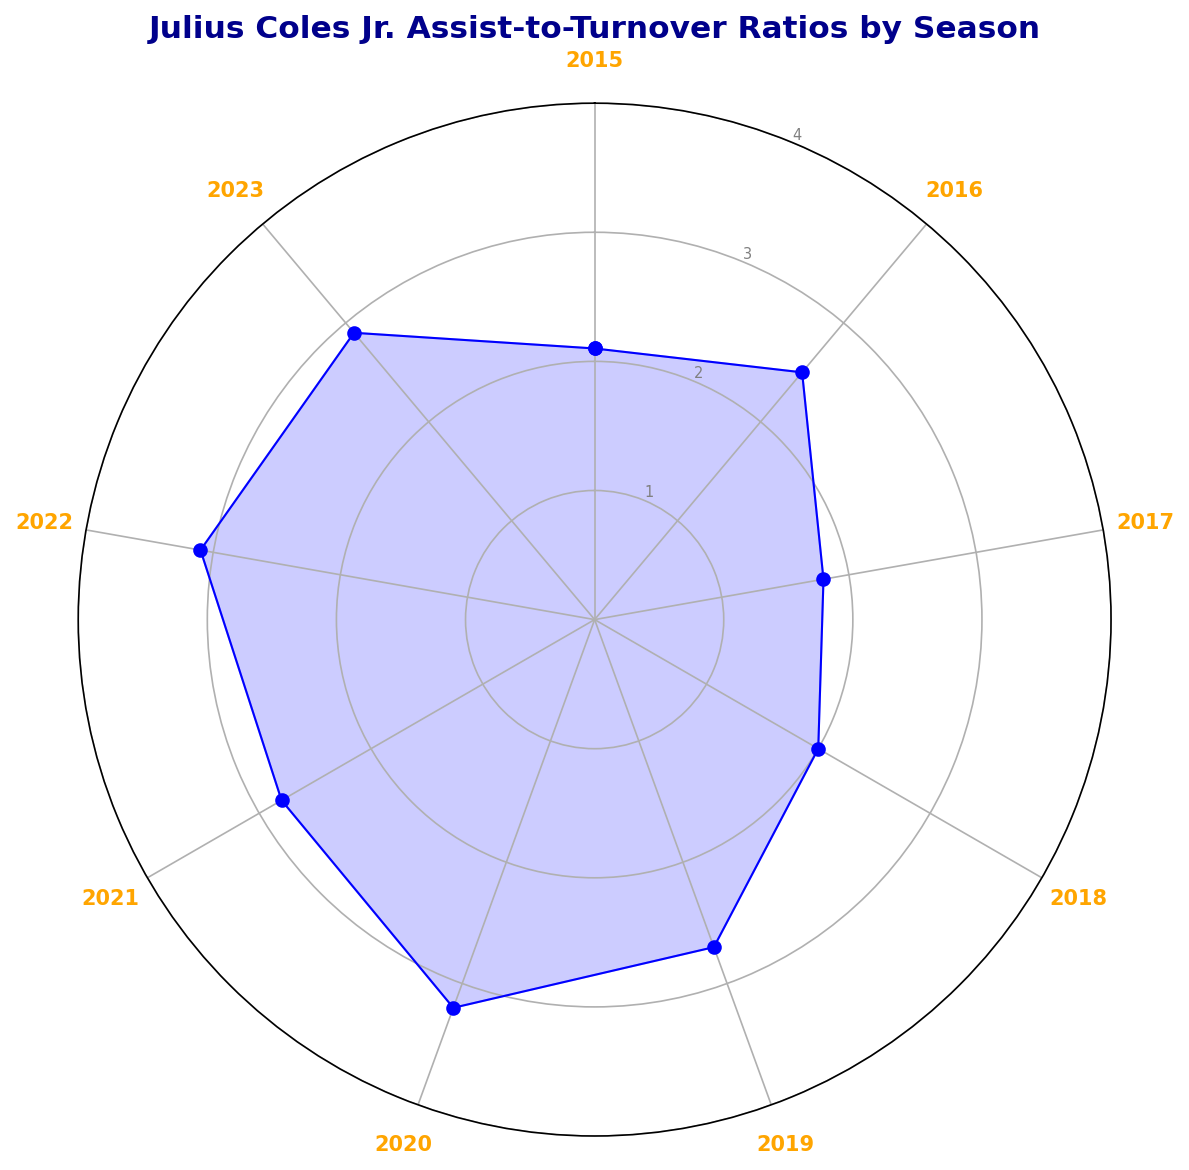Which season had the highest Assist-to-Turnover Ratio? The season with the highest ratio is indicated by the largest value on the chart. Upon inspecting the chart, the highest ratio is 3.2, which occurred in the 2020 season.
Answer: 2020 How did the ratio change from 2017 to 2018? In 2017, the ratio was 1.8 and in 2018 it was 2.0. To find the change, calculate 2.0 - 1.8 = 0.2. This indicates an increase of 0.2.
Answer: Increased by 0.2 What is the average Assist-to-Turnover Ratio over the entire period? To find the average, sum all the ratios and divide by the number of seasons. The ratios are 2.1, 2.5, 1.8, 2.0, 2.7, 3.2, 2.8, 3.1, and 2.9. Sum = 23.1. Number of seasons = 9. Average is 23.1 / 9 ≈ 2.57.
Answer: 2.57 Which season had the lowest Assist-to-Turnover Ratio? The season with the lowest ratio is indicated by the smallest value on the chart. From the chart, the lowest ratio, 1.8, occurred in the 2017 season.
Answer: 2017 How did the ratio change from 2019 to 2020? In 2019, the ratio was 2.7 and in 2020 it increased to 3.2. The change is calculated as 3.2 - 2.7 = 0.5. This means there was an increase of 0.5.
Answer: Increased by 0.5 What is the median Assist-to-Turnover Ratio over these seasons? To find the median, list the ratios in ascending order: 1.8, 2.0, 2.1, 2.5, 2.7, 2.8, 2.9, 3.1, 3.2. Since there are 9 data points, the median is the fifth value. The fifth value is 2.7.
Answer: 2.7 In which year did the Assist-to-Turnover Ratio first exceed 3.0? The first time the ratio exceeded 3.0 is marked by the first occurrence of a value greater than 3.0 on the chart. This first occurred in 2020 with a ratio of 3.2.
Answer: 2020 What is the Assist-to-Turnover Ratio difference between the highest and lowest values? Identify the highest value (3.2 in 2020) and the lowest value (1.8 in 2017), then calculate the difference as 3.2 - 1.8 = 1.4.
Answer: 1.4 How does the Assist-to-Turnover Ratio in 2023 compare to the ratio in 2021? The ratio in 2023 is 2.9, and in 2021 it is 2.8. Comparing these, 2.9 is higher than 2.8.
Answer: Higher in 2023 Which seasons had a ratio greater than 2.5? From the chart, the seasons with a ratio greater than 2.5 are 2016 (2.5), 2019 (2.7), 2020 (3.2), 2021 (2.8), 2022 (3.1), and 2023 (2.9).
Answer: 2016, 2019, 2020, 2021, 2022, 2023 